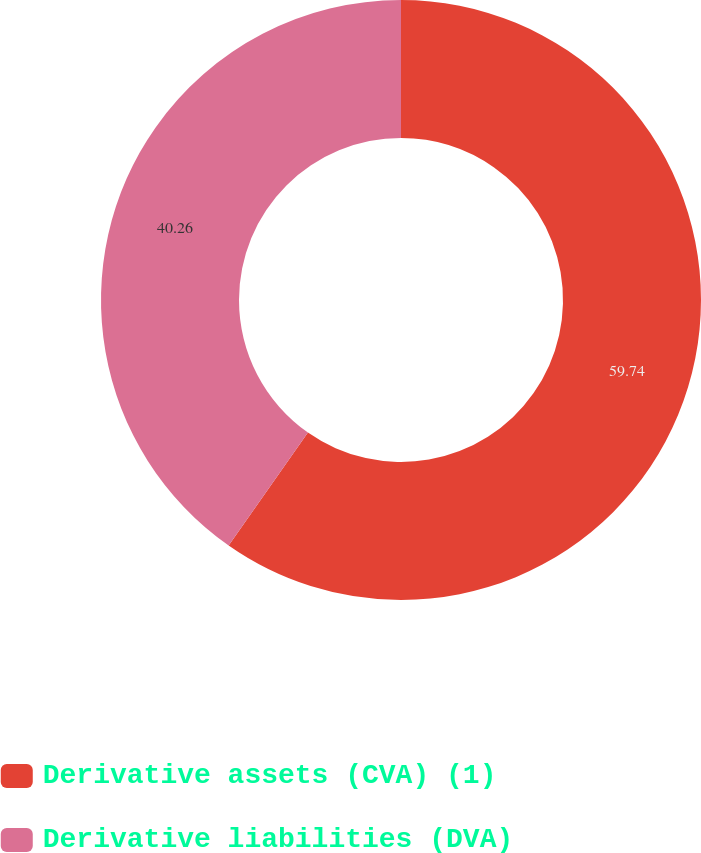Convert chart. <chart><loc_0><loc_0><loc_500><loc_500><pie_chart><fcel>Derivative assets (CVA) (1)<fcel>Derivative liabilities (DVA)<nl><fcel>59.74%<fcel>40.26%<nl></chart> 